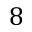Convert formula to latex. <formula><loc_0><loc_0><loc_500><loc_500>8</formula> 